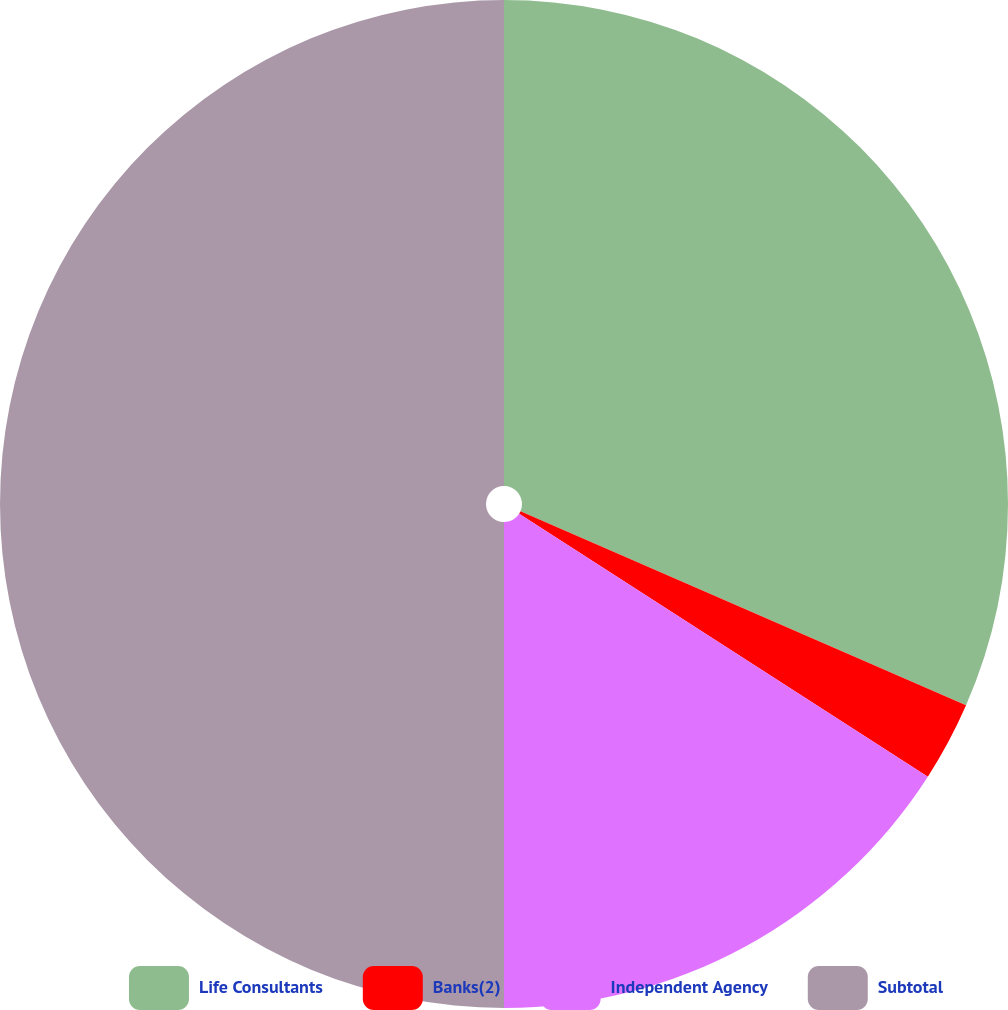Convert chart. <chart><loc_0><loc_0><loc_500><loc_500><pie_chart><fcel>Life Consultants<fcel>Banks(2)<fcel>Independent Agency<fcel>Subtotal<nl><fcel>31.54%<fcel>2.56%<fcel>15.9%<fcel>50.0%<nl></chart> 